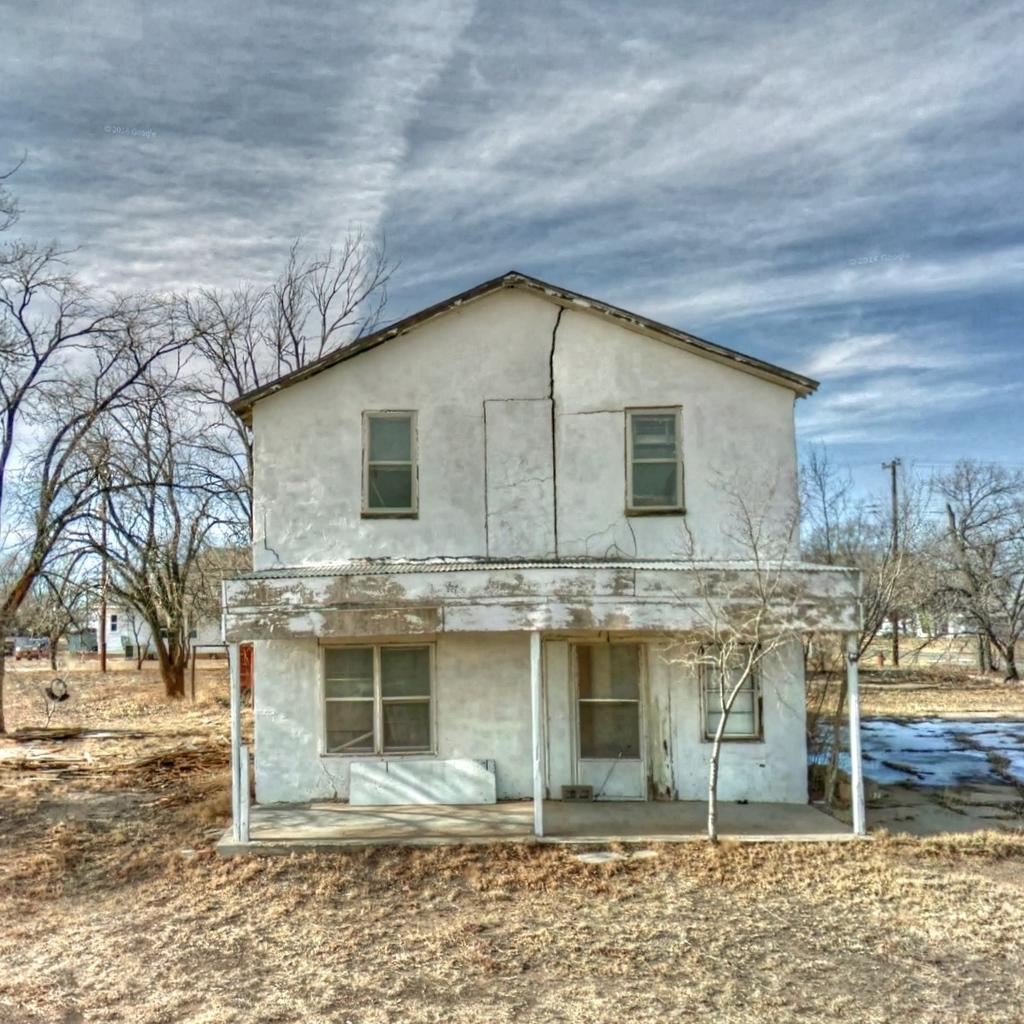Can you describe this image briefly? At the bottom, we see the dry grass. In the middle, we see the poles and a building in white color. There are trees, electric poles and the buildings in the background. At the top, we see the sky. 